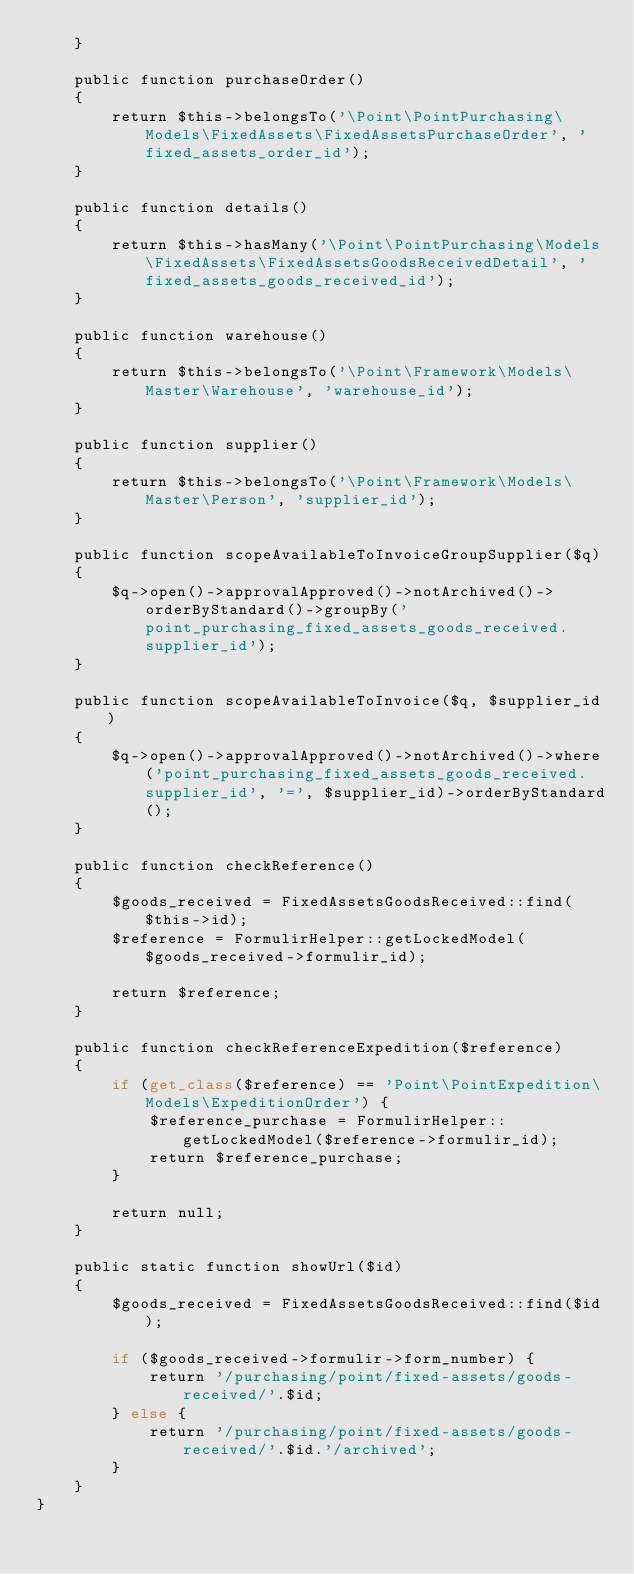Convert code to text. <code><loc_0><loc_0><loc_500><loc_500><_PHP_>    }

    public function purchaseOrder()
    {
        return $this->belongsTo('\Point\PointPurchasing\Models\FixedAssets\FixedAssetsPurchaseOrder', 'fixed_assets_order_id');
    }
    
    public function details()
    {
        return $this->hasMany('\Point\PointPurchasing\Models\FixedAssets\FixedAssetsGoodsReceivedDetail', 'fixed_assets_goods_received_id');
    }

    public function warehouse()
    {
        return $this->belongsTo('\Point\Framework\Models\Master\Warehouse', 'warehouse_id');
    }

    public function supplier()
    {
        return $this->belongsTo('\Point\Framework\Models\Master\Person', 'supplier_id');
    }

    public function scopeAvailableToInvoiceGroupSupplier($q)
    {
        $q->open()->approvalApproved()->notArchived()->orderByStandard()->groupBy('point_purchasing_fixed_assets_goods_received.supplier_id');
    }

    public function scopeAvailableToInvoice($q, $supplier_id)
    {
        $q->open()->approvalApproved()->notArchived()->where('point_purchasing_fixed_assets_goods_received.supplier_id', '=', $supplier_id)->orderByStandard();
    }

    public function checkReference()
    {
        $goods_received = FixedAssetsGoodsReceived::find($this->id);
        $reference = FormulirHelper::getLockedModel($goods_received->formulir_id);
        
        return $reference;
    }

    public function checkReferenceExpedition($reference)
    {
        if (get_class($reference) == 'Point\PointExpedition\Models\ExpeditionOrder') {
            $reference_purchase = FormulirHelper::getLockedModel($reference->formulir_id);
            return $reference_purchase;
        }

        return null;
    }

    public static function showUrl($id)
    {
        $goods_received = FixedAssetsGoodsReceived::find($id);

        if ($goods_received->formulir->form_number) {
            return '/purchasing/point/fixed-assets/goods-received/'.$id;
        } else {
            return '/purchasing/point/fixed-assets/goods-received/'.$id.'/archived';
        }
    }
}
</code> 